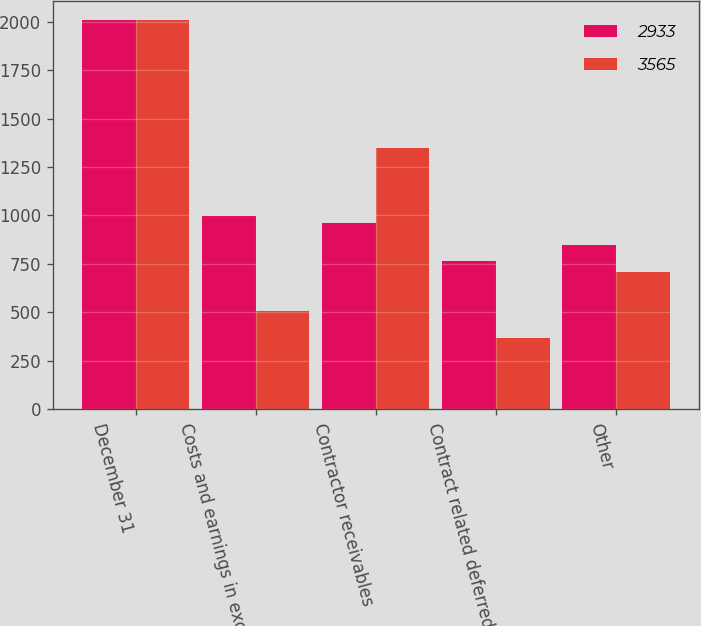Convert chart to OTSL. <chart><loc_0><loc_0><loc_500><loc_500><stacked_bar_chart><ecel><fcel>December 31<fcel>Costs and earnings in excess<fcel>Contractor receivables<fcel>Contract related deferred<fcel>Other<nl><fcel>2933<fcel>2007<fcel>995<fcel>960<fcel>763<fcel>847<nl><fcel>3565<fcel>2006<fcel>505<fcel>1349<fcel>369<fcel>710<nl></chart> 